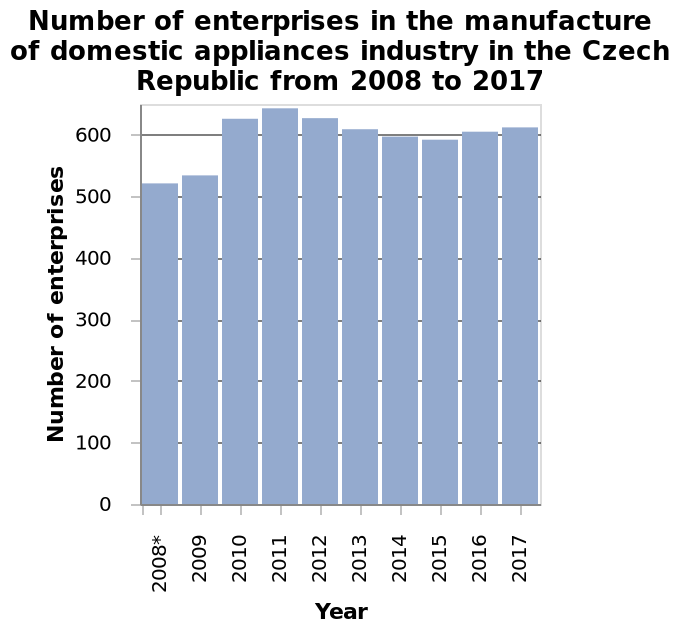<image>
In which year did the number of enterprises start to rise again after a decline? The number of enterprises started to rise again from 2016. Describe the following image in detail This is a bar plot titled Number of enterprises in the manufacture of domestic appliances industry in the Czech Republic from 2008 to 2017. Number of enterprises is shown on the y-axis. The x-axis plots Year with a categorical scale from 2008* to . What is the range of years covered in the bar plot? The bar plot covers the years from 2008 to 2017. When was the greatest number of enterprises recorded?  The greatest number of enterprises was recorded in 2011. Was the smallest number of enterprises recorded in 2011? No. The greatest number of enterprises was recorded in 2011. 